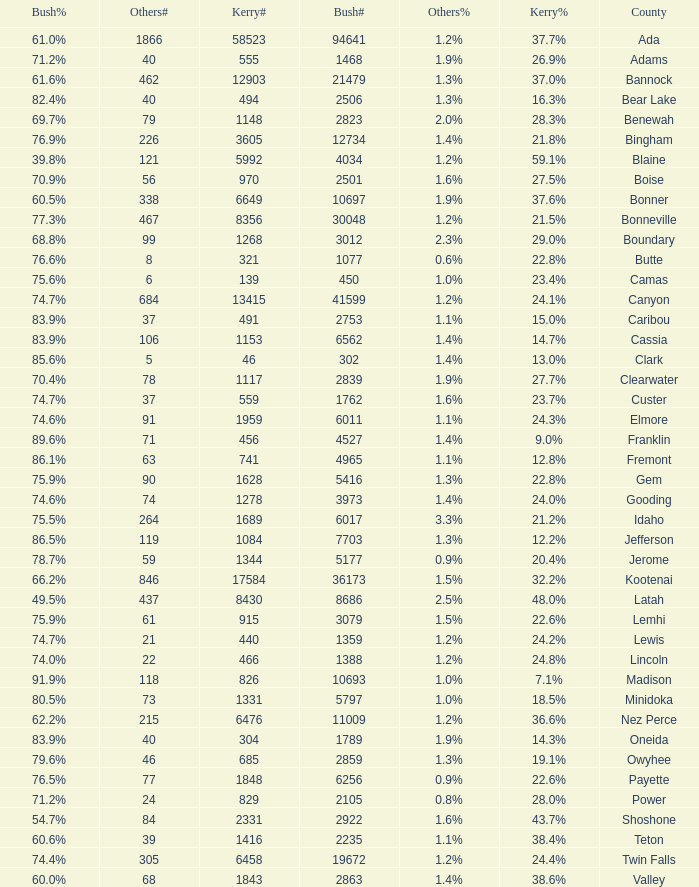What percentage of the votes were for others in the county where 462 people voted that way? 1.3%. 